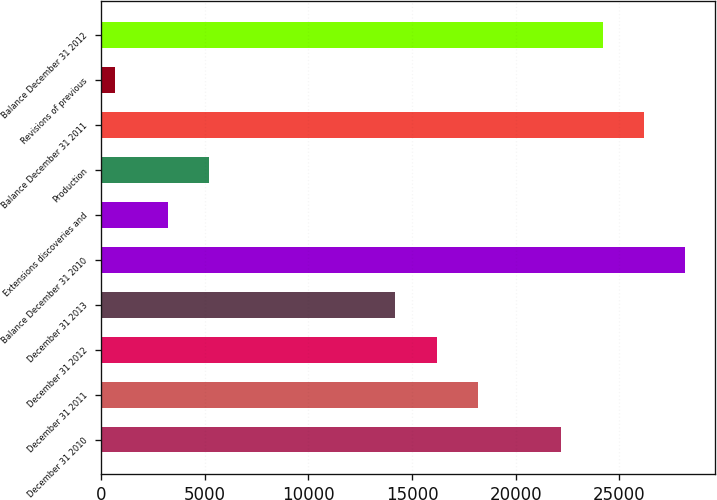<chart> <loc_0><loc_0><loc_500><loc_500><bar_chart><fcel>December 31 2010<fcel>December 31 2011<fcel>December 31 2012<fcel>December 31 2013<fcel>Balance December 31 2010<fcel>Extensions discoveries and<fcel>Production<fcel>Balance December 31 2011<fcel>Revisions of previous<fcel>Balance December 31 2012<nl><fcel>22184.6<fcel>18189.8<fcel>16192.4<fcel>14195<fcel>28176.8<fcel>3230<fcel>5227.4<fcel>26179.4<fcel>671<fcel>24182<nl></chart> 